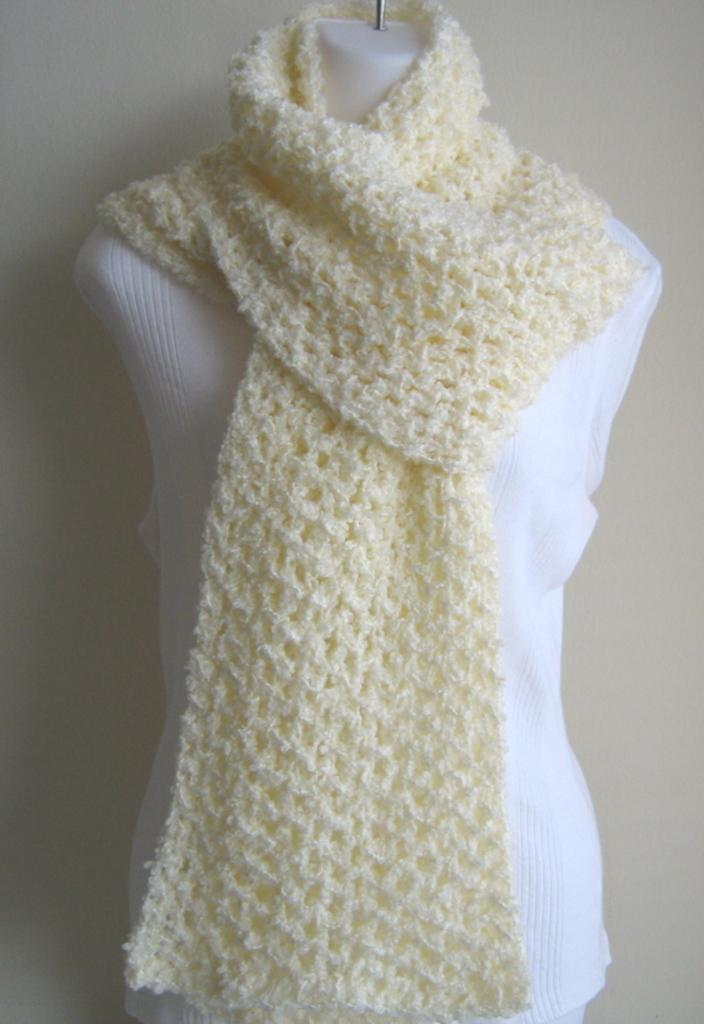How would you summarize this image in a sentence or two? In this picture we can see a mannequin with clothes on it and in the background we can see the surface. 